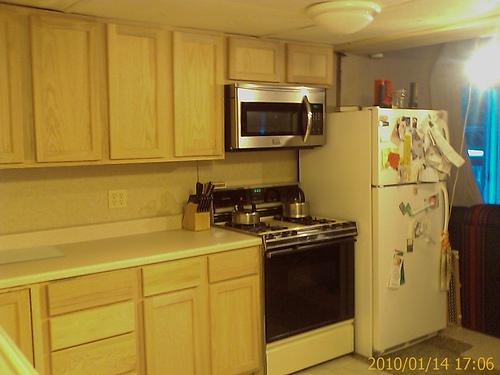Are the cabinets two colors?
Keep it brief. No. Is the refrigerator black?
Answer briefly. No. What color is the stove?
Write a very short answer. Black. What color is the microwave?
Give a very brief answer. Silver. What is on the refrigerator?
Answer briefly. Papers. Is this house occupied?
Be succinct. Yes. Does this kitchen look usable?
Concise answer only. Yes. Is there more than one light source for this kitchen?
Answer briefly. Yes. What type of refrigerator is that?
Answer briefly. Frigidaire. Is the stove gas or electric?
Short answer required. Gas. Is this an electric stove?
Short answer required. No. Is there enough counter space to prepare an elaborate meal?
Concise answer only. Yes. How many fan blades are shown?
Write a very short answer. 0. Where is the oven?
Answer briefly. Kitchen. 